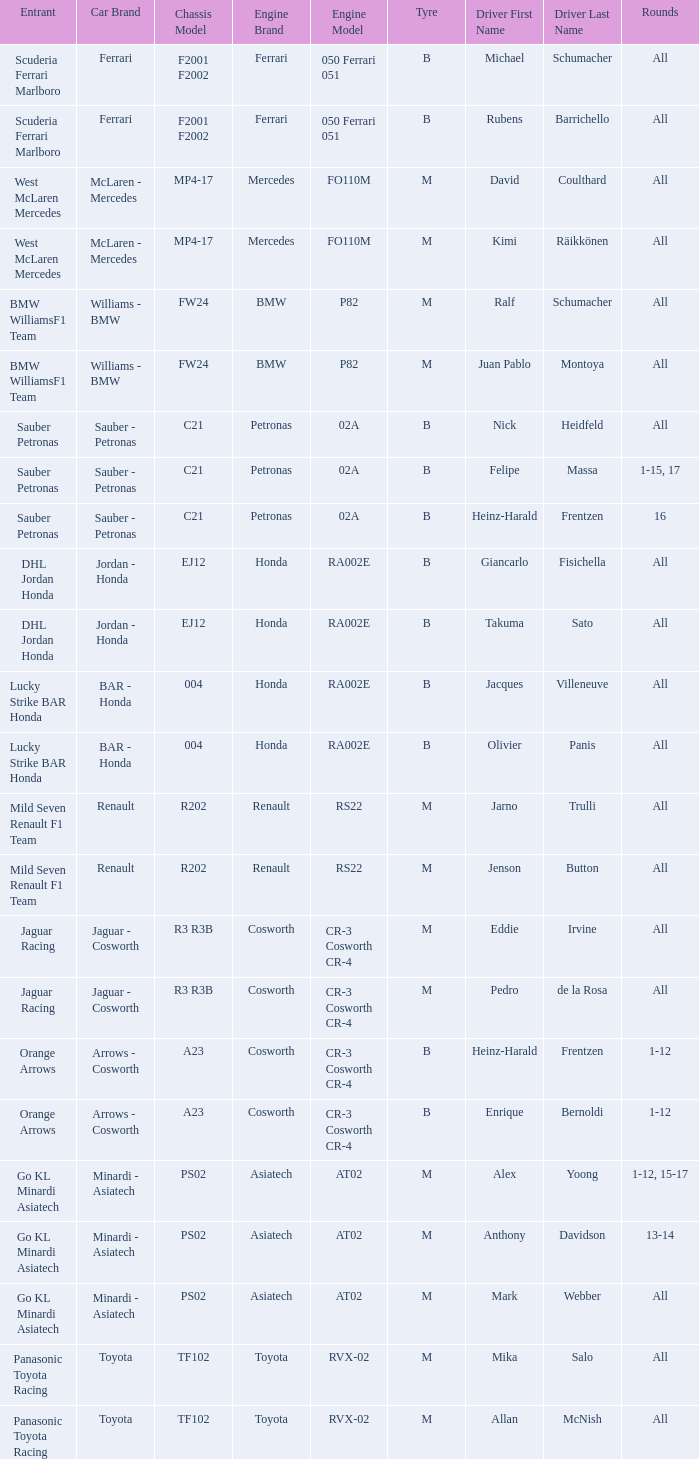What is the tyre when the engine is asiatech at02 and the driver is alex yoong? M. Help me parse the entirety of this table. {'header': ['Entrant', 'Car Brand', 'Chassis Model', 'Engine Brand', 'Engine Model', 'Tyre', 'Driver First Name', 'Driver Last Name', 'Rounds'], 'rows': [['Scuderia Ferrari Marlboro', 'Ferrari', 'F2001 F2002', 'Ferrari', '050 Ferrari 051', 'B', 'Michael', 'Schumacher', 'All'], ['Scuderia Ferrari Marlboro', 'Ferrari', 'F2001 F2002', 'Ferrari', '050 Ferrari 051', 'B', 'Rubens', 'Barrichello', 'All'], ['West McLaren Mercedes', 'McLaren - Mercedes', 'MP4-17', 'Mercedes', 'FO110M', 'M', 'David', 'Coulthard', 'All'], ['West McLaren Mercedes', 'McLaren - Mercedes', 'MP4-17', 'Mercedes', 'FO110M', 'M', 'Kimi', 'Räikkönen', 'All'], ['BMW WilliamsF1 Team', 'Williams - BMW', 'FW24', 'BMW', 'P82', 'M', 'Ralf', 'Schumacher', 'All'], ['BMW WilliamsF1 Team', 'Williams - BMW', 'FW24', 'BMW', 'P82', 'M', 'Juan Pablo', 'Montoya', 'All'], ['Sauber Petronas', 'Sauber - Petronas', 'C21', 'Petronas', '02A', 'B', 'Nick', 'Heidfeld', 'All'], ['Sauber Petronas', 'Sauber - Petronas', 'C21', 'Petronas', '02A', 'B', 'Felipe', 'Massa', '1-15, 17'], ['Sauber Petronas', 'Sauber - Petronas', 'C21', 'Petronas', '02A', 'B', 'Heinz-Harald', 'Frentzen', '16'], ['DHL Jordan Honda', 'Jordan - Honda', 'EJ12', 'Honda', 'RA002E', 'B', 'Giancarlo', 'Fisichella', 'All'], ['DHL Jordan Honda', 'Jordan - Honda', 'EJ12', 'Honda', 'RA002E', 'B', 'Takuma', 'Sato', 'All'], ['Lucky Strike BAR Honda', 'BAR - Honda', '004', 'Honda', 'RA002E', 'B', 'Jacques', 'Villeneuve', 'All'], ['Lucky Strike BAR Honda', 'BAR - Honda', '004', 'Honda', 'RA002E', 'B', 'Olivier', 'Panis', 'All'], ['Mild Seven Renault F1 Team', 'Renault', 'R202', 'Renault', 'RS22', 'M', 'Jarno', 'Trulli', 'All'], ['Mild Seven Renault F1 Team', 'Renault', 'R202', 'Renault', 'RS22', 'M', 'Jenson', 'Button', 'All'], ['Jaguar Racing', 'Jaguar - Cosworth', 'R3 R3B', 'Cosworth', 'CR-3 Cosworth CR-4', 'M', 'Eddie', 'Irvine', 'All'], ['Jaguar Racing', 'Jaguar - Cosworth', 'R3 R3B', 'Cosworth', 'CR-3 Cosworth CR-4', 'M', 'Pedro', 'de la Rosa', 'All'], ['Orange Arrows', 'Arrows - Cosworth', 'A23', 'Cosworth', 'CR-3 Cosworth CR-4', 'B', 'Heinz-Harald', 'Frentzen', '1-12'], ['Orange Arrows', 'Arrows - Cosworth', 'A23', 'Cosworth', 'CR-3 Cosworth CR-4', 'B', 'Enrique', 'Bernoldi', '1-12'], ['Go KL Minardi Asiatech', 'Minardi - Asiatech', 'PS02', 'Asiatech', 'AT02', 'M', 'Alex', 'Yoong', '1-12, 15-17'], ['Go KL Minardi Asiatech', 'Minardi - Asiatech', 'PS02', 'Asiatech', 'AT02', 'M', 'Anthony', 'Davidson', '13-14'], ['Go KL Minardi Asiatech', 'Minardi - Asiatech', 'PS02', 'Asiatech', 'AT02', 'M', 'Mark', 'Webber', 'All'], ['Panasonic Toyota Racing', 'Toyota', 'TF102', 'Toyota', 'RVX-02', 'M', 'Mika', 'Salo', 'All'], ['Panasonic Toyota Racing', 'Toyota', 'TF102', 'Toyota', 'RVX-02', 'M', 'Allan', 'McNish', 'All']]} 